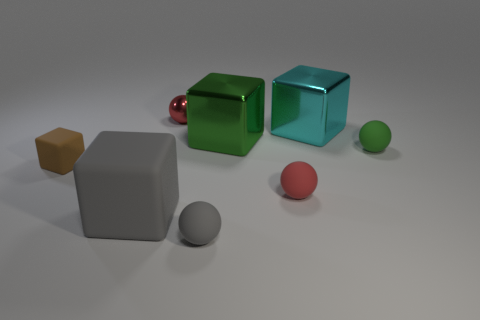Subtract all red spheres. How many were subtracted if there are1red spheres left? 1 Add 1 tiny brown matte things. How many objects exist? 9 Subtract all gray balls. How many balls are left? 3 Subtract all large cyan cubes. How many cubes are left? 3 Subtract all green cubes. Subtract all red metal things. How many objects are left? 6 Add 8 gray matte spheres. How many gray matte spheres are left? 9 Add 1 large cyan blocks. How many large cyan blocks exist? 2 Subtract 0 red cylinders. How many objects are left? 8 Subtract 2 balls. How many balls are left? 2 Subtract all gray spheres. Subtract all yellow blocks. How many spheres are left? 3 